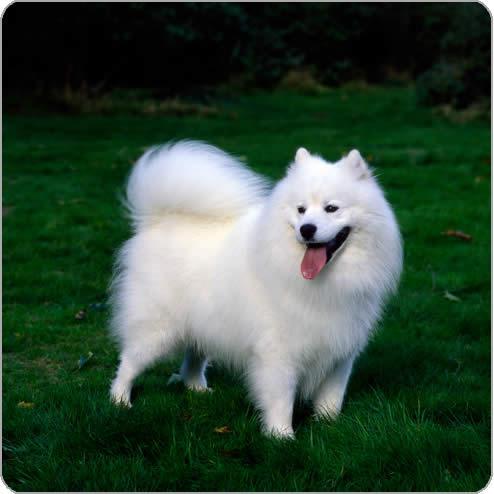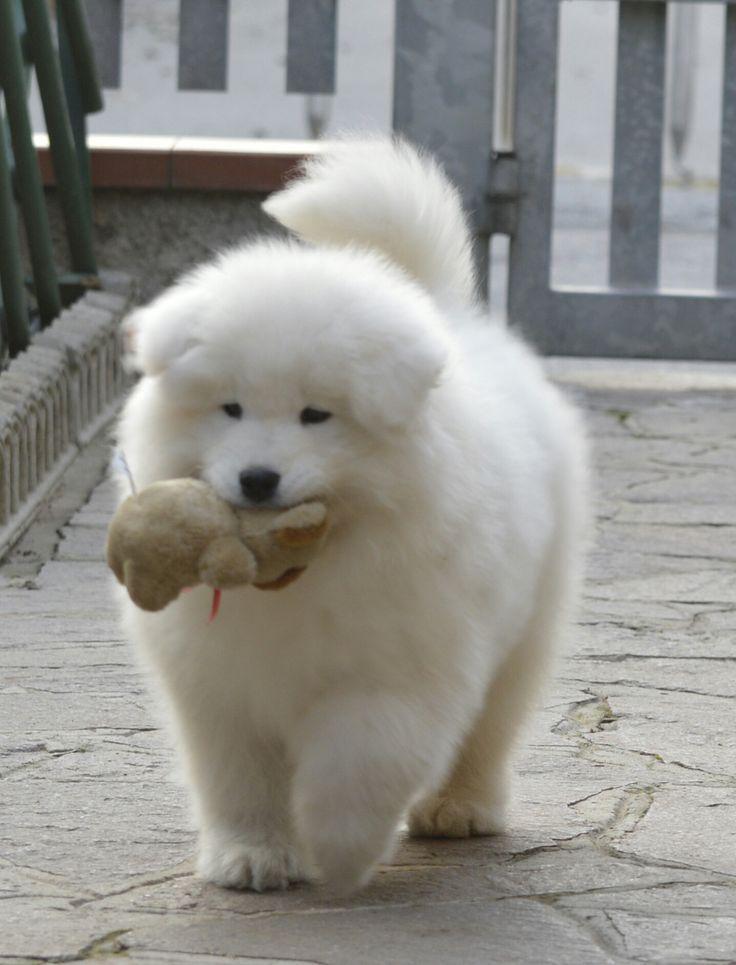The first image is the image on the left, the second image is the image on the right. Considering the images on both sides, is "All white dogs are sitting in green grass." valid? Answer yes or no. No. The first image is the image on the left, the second image is the image on the right. Given the left and right images, does the statement "At least one of the images shows a dog sitting." hold true? Answer yes or no. No. 